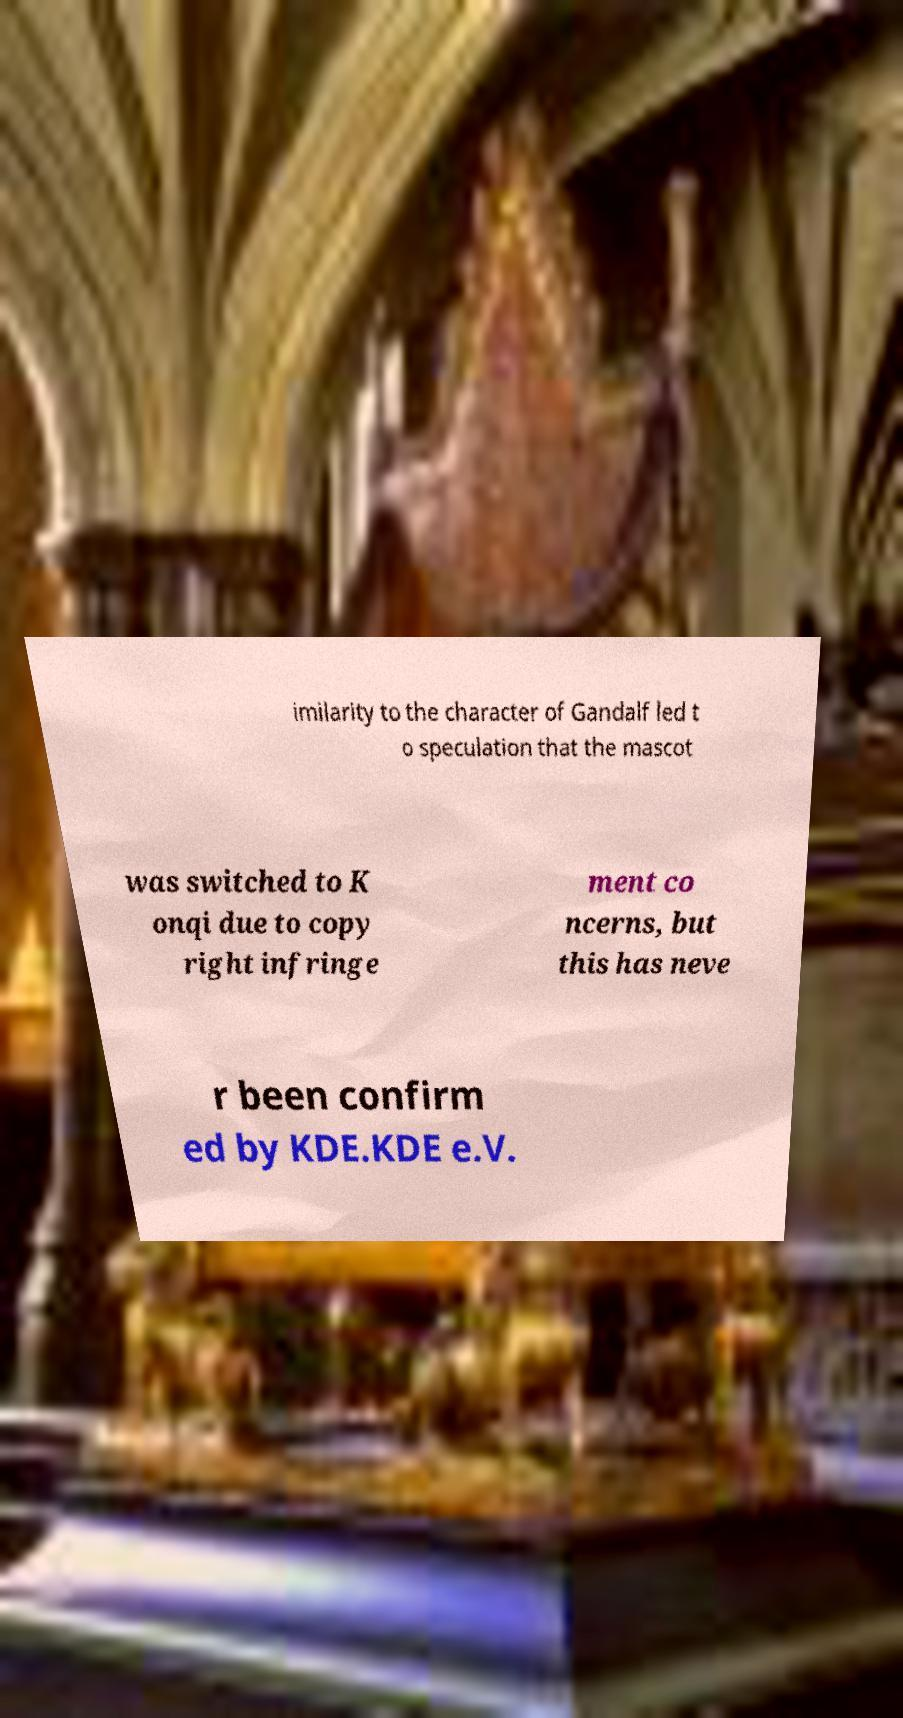Can you read and provide the text displayed in the image?This photo seems to have some interesting text. Can you extract and type it out for me? imilarity to the character of Gandalf led t o speculation that the mascot was switched to K onqi due to copy right infringe ment co ncerns, but this has neve r been confirm ed by KDE.KDE e.V. 